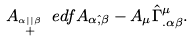Convert formula to latex. <formula><loc_0><loc_0><loc_500><loc_500>A _ { \stackrel { \alpha | | \beta } { + } } \ e d f A _ { \alpha \hat { , } \beta } - A _ { \mu } \hat { \Gamma } ^ { \mu } _ { . \alpha \beta } .</formula> 